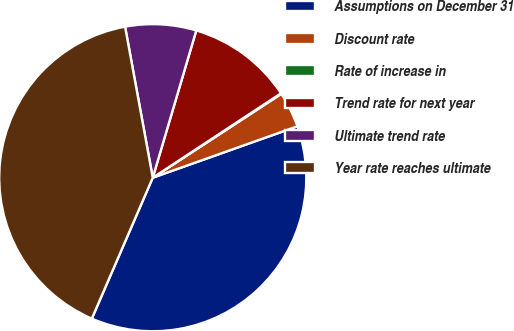Convert chart to OTSL. <chart><loc_0><loc_0><loc_500><loc_500><pie_chart><fcel>Assumptions on December 31<fcel>Discount rate<fcel>Rate of increase in<fcel>Trend rate for next year<fcel>Ultimate trend rate<fcel>Year rate reaches ultimate<nl><fcel>36.93%<fcel>3.76%<fcel>0.07%<fcel>11.16%<fcel>7.46%<fcel>40.62%<nl></chart> 